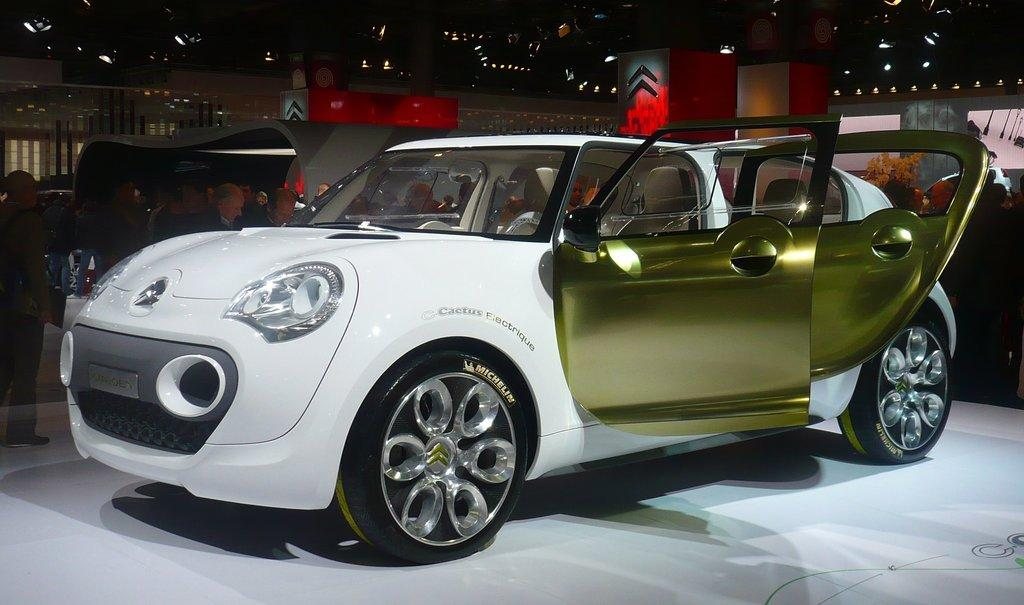What is placed on the floor in the image? There is a car on the floor in the image. Who or what else can be seen on the floor in the image? There are people standing on the floor in the image. What can be seen on the right side of the image? There is a plant on the right side of the image. What is visible in the background of the image? There are buildings visible in the background of the image. What other objects are on the floor in the image? There are vehicles on the floor in the image. What type of bird can be seen drawing attention to itself in the image? There is no bird present in the image; it features a car, people, a plant, buildings, and vehicles. 